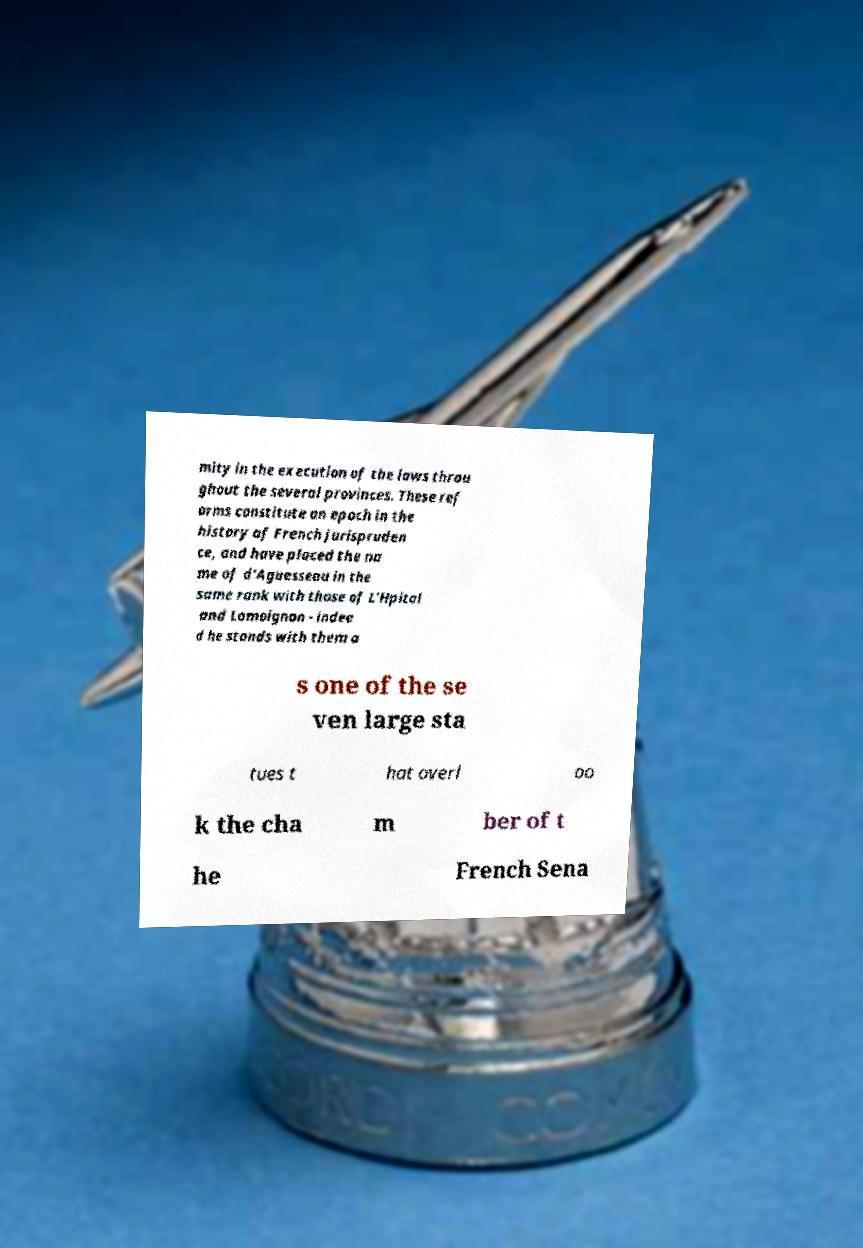There's text embedded in this image that I need extracted. Can you transcribe it verbatim? mity in the execution of the laws throu ghout the several provinces. These ref orms constitute an epoch in the history of French jurispruden ce, and have placed the na me of d'Aguesseau in the same rank with those of L'Hpital and Lamoignon - indee d he stands with them a s one of the se ven large sta tues t hat overl oo k the cha m ber of t he French Sena 